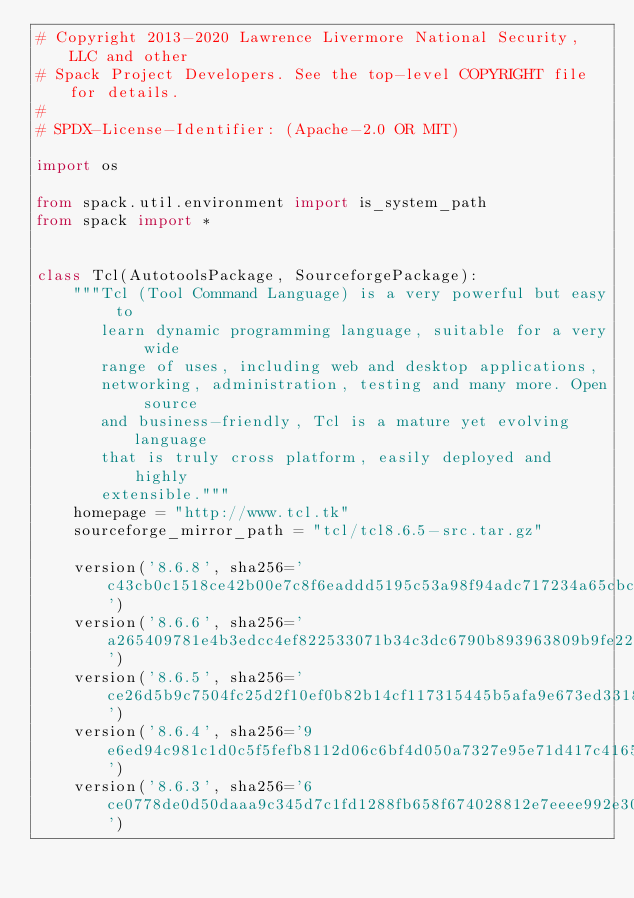<code> <loc_0><loc_0><loc_500><loc_500><_Python_># Copyright 2013-2020 Lawrence Livermore National Security, LLC and other
# Spack Project Developers. See the top-level COPYRIGHT file for details.
#
# SPDX-License-Identifier: (Apache-2.0 OR MIT)

import os

from spack.util.environment import is_system_path
from spack import *


class Tcl(AutotoolsPackage, SourceforgePackage):
    """Tcl (Tool Command Language) is a very powerful but easy to
       learn dynamic programming language, suitable for a very wide
       range of uses, including web and desktop applications,
       networking, administration, testing and many more. Open source
       and business-friendly, Tcl is a mature yet evolving language
       that is truly cross platform, easily deployed and highly
       extensible."""
    homepage = "http://www.tcl.tk"
    sourceforge_mirror_path = "tcl/tcl8.6.5-src.tar.gz"

    version('8.6.8', sha256='c43cb0c1518ce42b00e7c8f6eaddd5195c53a98f94adc717234a65cbcfd3f96a')
    version('8.6.6', sha256='a265409781e4b3edcc4ef822533071b34c3dc6790b893963809b9fe221befe07')
    version('8.6.5', sha256='ce26d5b9c7504fc25d2f10ef0b82b14cf117315445b5afa9e673ed331830fb53')
    version('8.6.4', sha256='9e6ed94c981c1d0c5f5fefb8112d06c6bf4d050a7327e95e71d417c416519c8d')
    version('8.6.3', sha256='6ce0778de0d50daaa9c345d7c1fd1288fb658f674028812e7eeee992e3051005')</code> 